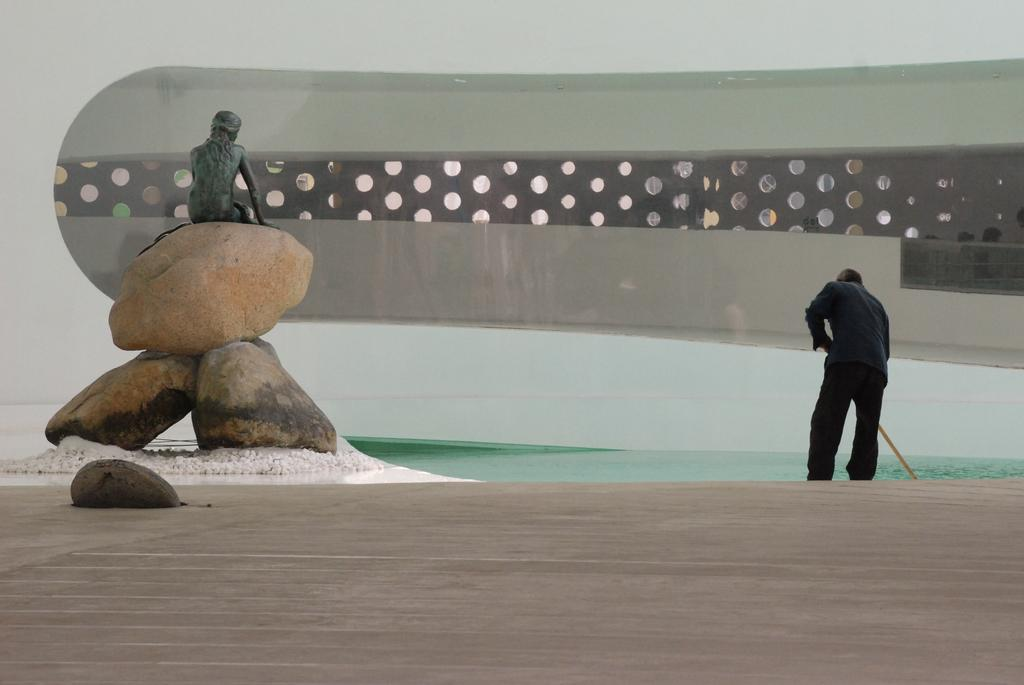What is the man in the image doing? The man is standing in the image and holding a stick. What can be seen on the rock in the image? There is a sculpture on a rock in the image. What is visible in the image besides the man and the sculpture? There is water visible in the image. What is in the background of the image? There is a wall in the background of the image. How many hospitals are visible in the image? There are no hospitals visible in the image. What type of tramp is present in the image? There is no tramp present in the image. 